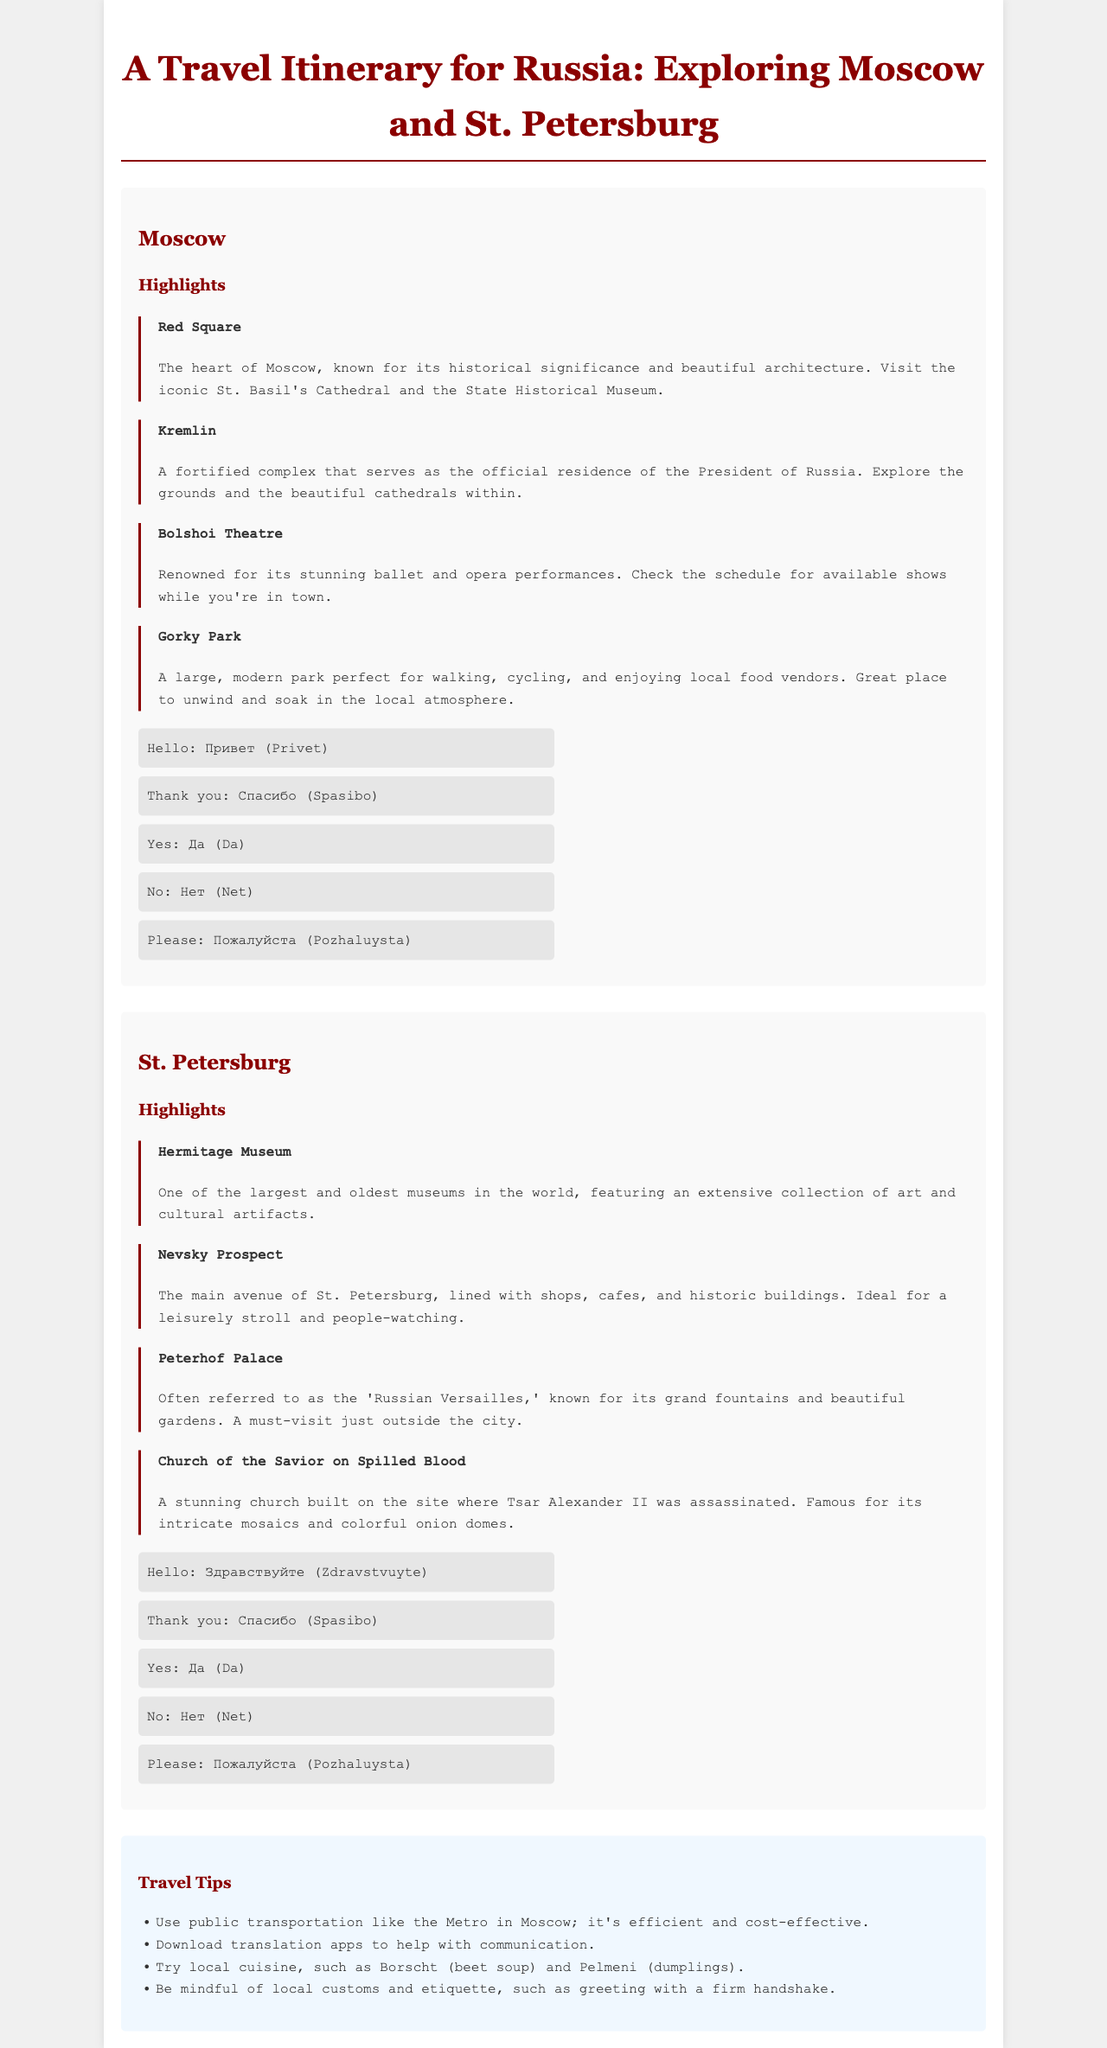What is the name of the iconic cathedral in Red Square? The Red Square section mentions St. Basil's Cathedral as the iconic cathedral.
Answer: St. Basil's Cathedral What is the main avenue of St. Petersburg? The St. Petersburg section highlights Nevsky Prospect as the main avenue.
Answer: Nevsky Prospect How many highlights are listed for Moscow? The Moscow section contains four highlights listed under the Highlights heading.
Answer: Four What Russian phrase means "Thank you"? The document includes "Спасибо (Spasibo)" as the translation for "Thank you".
Answer: Спасибо (Spasibo) Which palace is referred to as the 'Russian Versailles'? The highlight about Peterhof Palace refers to it as the 'Russian Versailles'.
Answer: Peterhof Palace What is one local dish suggested to try? The travel tips mention Borscht as a local cuisine to try.
Answer: Borscht Which city is known for the Hermitage Museum? The document states that the Hermitage Museum is in St. Petersburg.
Answer: St. Petersburg What type of performances is the Bolshoi Theatre renowned for? The document mentions that the Bolshoi Theatre is renowned for ballet and opera performances.
Answer: Ballet and opera What is a recommended transportation method in Moscow? The travel tips section mentions using public transportation like the Metro in Moscow.
Answer: Metro 